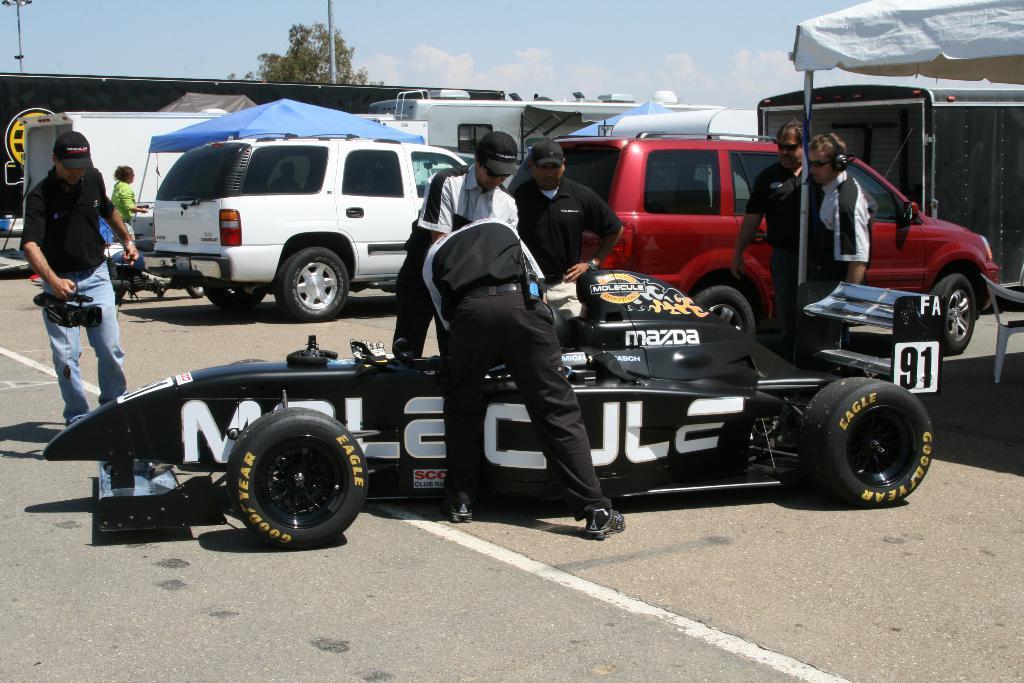Please provide a concise description of this image. In this image I can see vehicles. There are group of people, there are poles, there is a tree and in the background there is sky. 